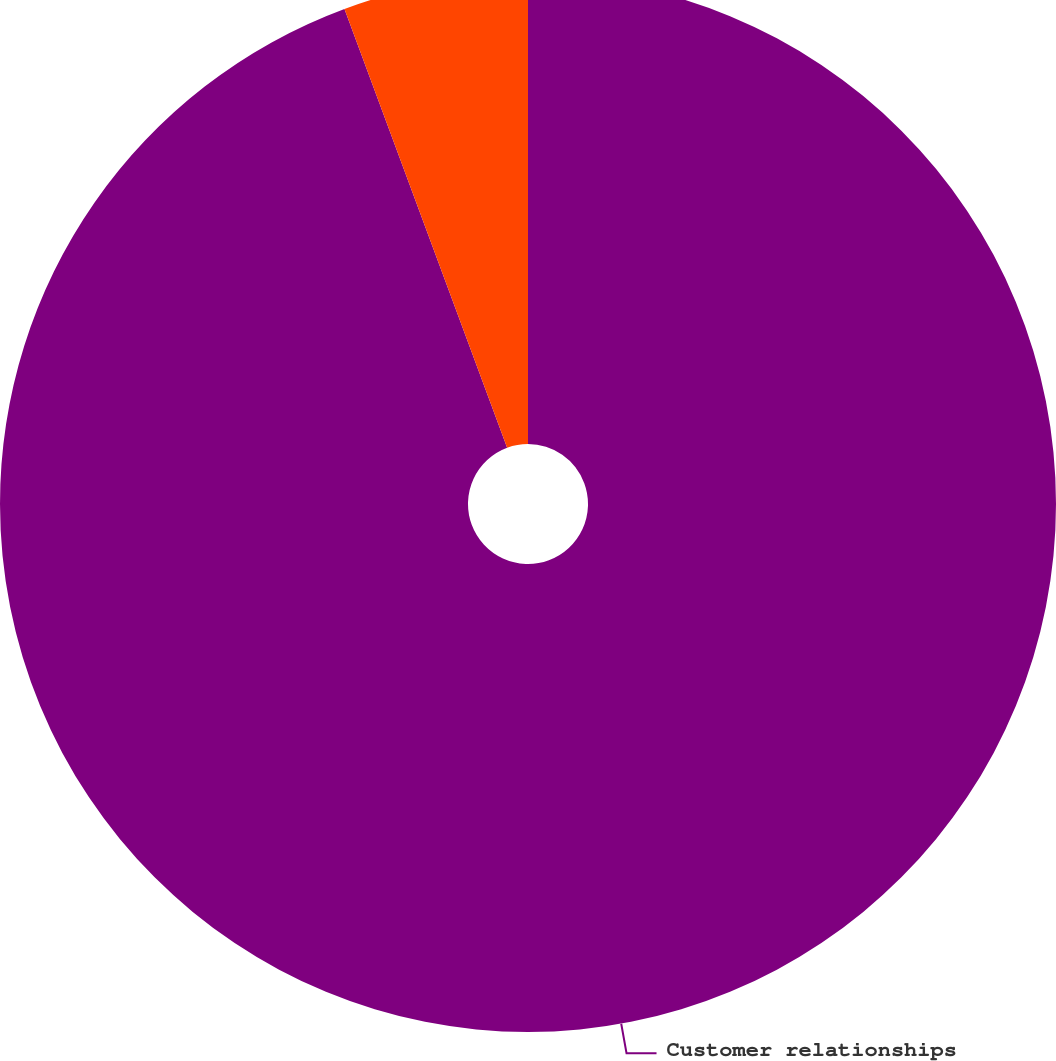Convert chart. <chart><loc_0><loc_0><loc_500><loc_500><pie_chart><fcel>Customer relationships<fcel>Patents and other<nl><fcel>94.35%<fcel>5.65%<nl></chart> 